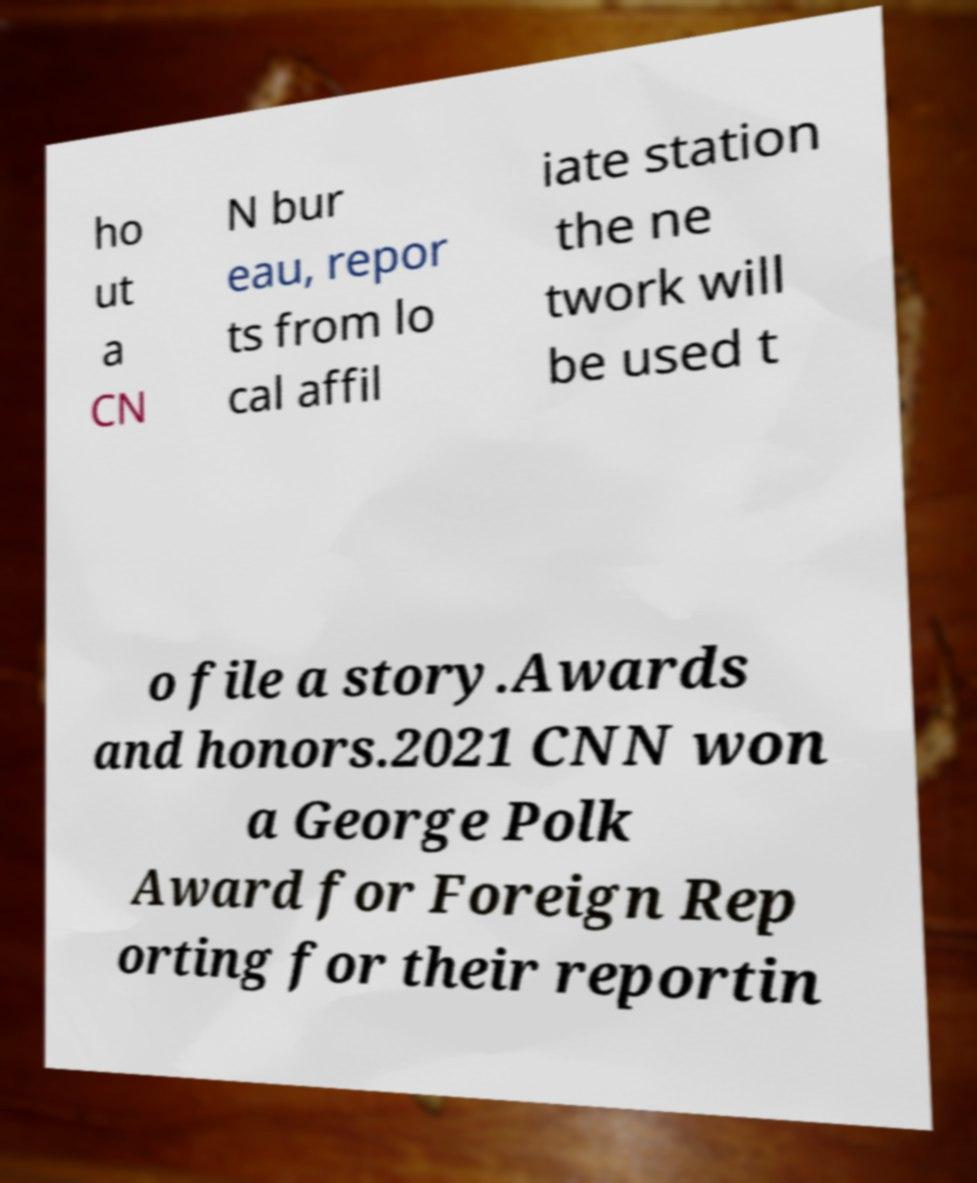Can you read and provide the text displayed in the image?This photo seems to have some interesting text. Can you extract and type it out for me? ho ut a CN N bur eau, repor ts from lo cal affil iate station the ne twork will be used t o file a story.Awards and honors.2021 CNN won a George Polk Award for Foreign Rep orting for their reportin 